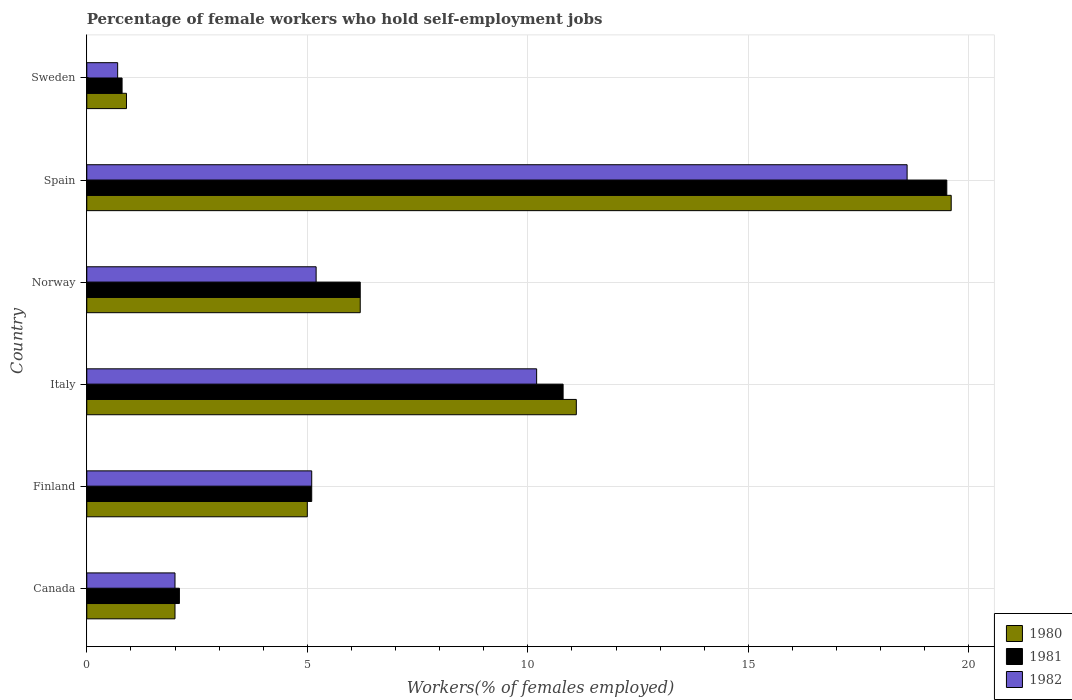How many different coloured bars are there?
Make the answer very short. 3. How many groups of bars are there?
Your answer should be very brief. 6. Are the number of bars per tick equal to the number of legend labels?
Offer a terse response. Yes. Are the number of bars on each tick of the Y-axis equal?
Provide a succinct answer. Yes. How many bars are there on the 1st tick from the bottom?
Give a very brief answer. 3. What is the percentage of self-employed female workers in 1982 in Sweden?
Offer a terse response. 0.7. Across all countries, what is the maximum percentage of self-employed female workers in 1980?
Give a very brief answer. 19.6. Across all countries, what is the minimum percentage of self-employed female workers in 1982?
Your answer should be compact. 0.7. In which country was the percentage of self-employed female workers in 1982 maximum?
Keep it short and to the point. Spain. In which country was the percentage of self-employed female workers in 1980 minimum?
Offer a very short reply. Sweden. What is the total percentage of self-employed female workers in 1981 in the graph?
Provide a succinct answer. 44.5. What is the difference between the percentage of self-employed female workers in 1982 in Canada and that in Finland?
Keep it short and to the point. -3.1. What is the difference between the percentage of self-employed female workers in 1982 in Norway and the percentage of self-employed female workers in 1981 in Sweden?
Make the answer very short. 4.4. What is the average percentage of self-employed female workers in 1981 per country?
Offer a very short reply. 7.42. What is the difference between the percentage of self-employed female workers in 1981 and percentage of self-employed female workers in 1982 in Spain?
Ensure brevity in your answer.  0.9. In how many countries, is the percentage of self-employed female workers in 1980 greater than 9 %?
Keep it short and to the point. 2. What is the ratio of the percentage of self-employed female workers in 1981 in Italy to that in Spain?
Offer a terse response. 0.55. Is the percentage of self-employed female workers in 1982 in Finland less than that in Italy?
Offer a terse response. Yes. What is the difference between the highest and the second highest percentage of self-employed female workers in 1980?
Provide a succinct answer. 8.5. What is the difference between the highest and the lowest percentage of self-employed female workers in 1981?
Keep it short and to the point. 18.7. In how many countries, is the percentage of self-employed female workers in 1980 greater than the average percentage of self-employed female workers in 1980 taken over all countries?
Ensure brevity in your answer.  2. What does the 3rd bar from the bottom in Italy represents?
Your answer should be compact. 1982. Is it the case that in every country, the sum of the percentage of self-employed female workers in 1980 and percentage of self-employed female workers in 1981 is greater than the percentage of self-employed female workers in 1982?
Offer a terse response. Yes. How many bars are there?
Ensure brevity in your answer.  18. How many countries are there in the graph?
Provide a short and direct response. 6. What is the difference between two consecutive major ticks on the X-axis?
Give a very brief answer. 5. Does the graph contain grids?
Provide a short and direct response. Yes. How many legend labels are there?
Keep it short and to the point. 3. How are the legend labels stacked?
Offer a very short reply. Vertical. What is the title of the graph?
Your answer should be compact. Percentage of female workers who hold self-employment jobs. What is the label or title of the X-axis?
Keep it short and to the point. Workers(% of females employed). What is the Workers(% of females employed) in 1981 in Canada?
Your answer should be compact. 2.1. What is the Workers(% of females employed) in 1982 in Canada?
Provide a succinct answer. 2. What is the Workers(% of females employed) of 1980 in Finland?
Offer a very short reply. 5. What is the Workers(% of females employed) of 1981 in Finland?
Your response must be concise. 5.1. What is the Workers(% of females employed) of 1982 in Finland?
Offer a very short reply. 5.1. What is the Workers(% of females employed) of 1980 in Italy?
Give a very brief answer. 11.1. What is the Workers(% of females employed) of 1981 in Italy?
Keep it short and to the point. 10.8. What is the Workers(% of females employed) in 1982 in Italy?
Offer a terse response. 10.2. What is the Workers(% of females employed) in 1980 in Norway?
Provide a succinct answer. 6.2. What is the Workers(% of females employed) in 1981 in Norway?
Provide a short and direct response. 6.2. What is the Workers(% of females employed) of 1982 in Norway?
Your response must be concise. 5.2. What is the Workers(% of females employed) in 1980 in Spain?
Provide a short and direct response. 19.6. What is the Workers(% of females employed) in 1982 in Spain?
Give a very brief answer. 18.6. What is the Workers(% of females employed) in 1980 in Sweden?
Offer a very short reply. 0.9. What is the Workers(% of females employed) in 1981 in Sweden?
Provide a short and direct response. 0.8. What is the Workers(% of females employed) in 1982 in Sweden?
Provide a short and direct response. 0.7. Across all countries, what is the maximum Workers(% of females employed) in 1980?
Give a very brief answer. 19.6. Across all countries, what is the maximum Workers(% of females employed) in 1982?
Give a very brief answer. 18.6. Across all countries, what is the minimum Workers(% of females employed) of 1980?
Provide a short and direct response. 0.9. Across all countries, what is the minimum Workers(% of females employed) of 1981?
Your answer should be compact. 0.8. Across all countries, what is the minimum Workers(% of females employed) of 1982?
Offer a very short reply. 0.7. What is the total Workers(% of females employed) of 1980 in the graph?
Your answer should be compact. 44.8. What is the total Workers(% of females employed) of 1981 in the graph?
Your answer should be very brief. 44.5. What is the total Workers(% of females employed) in 1982 in the graph?
Your answer should be compact. 41.8. What is the difference between the Workers(% of females employed) in 1980 in Canada and that in Italy?
Make the answer very short. -9.1. What is the difference between the Workers(% of females employed) of 1982 in Canada and that in Italy?
Make the answer very short. -8.2. What is the difference between the Workers(% of females employed) in 1980 in Canada and that in Spain?
Provide a short and direct response. -17.6. What is the difference between the Workers(% of females employed) of 1981 in Canada and that in Spain?
Your response must be concise. -17.4. What is the difference between the Workers(% of females employed) of 1982 in Canada and that in Spain?
Make the answer very short. -16.6. What is the difference between the Workers(% of females employed) in 1980 in Canada and that in Sweden?
Offer a terse response. 1.1. What is the difference between the Workers(% of females employed) of 1981 in Finland and that in Italy?
Ensure brevity in your answer.  -5.7. What is the difference between the Workers(% of females employed) in 1982 in Finland and that in Italy?
Offer a terse response. -5.1. What is the difference between the Workers(% of females employed) in 1980 in Finland and that in Spain?
Give a very brief answer. -14.6. What is the difference between the Workers(% of females employed) of 1981 in Finland and that in Spain?
Provide a short and direct response. -14.4. What is the difference between the Workers(% of females employed) in 1980 in Finland and that in Sweden?
Offer a terse response. 4.1. What is the difference between the Workers(% of females employed) of 1981 in Finland and that in Sweden?
Offer a terse response. 4.3. What is the difference between the Workers(% of females employed) of 1982 in Finland and that in Sweden?
Your answer should be compact. 4.4. What is the difference between the Workers(% of females employed) of 1980 in Italy and that in Norway?
Ensure brevity in your answer.  4.9. What is the difference between the Workers(% of females employed) of 1981 in Italy and that in Spain?
Offer a terse response. -8.7. What is the difference between the Workers(% of females employed) of 1982 in Italy and that in Spain?
Keep it short and to the point. -8.4. What is the difference between the Workers(% of females employed) of 1980 in Italy and that in Sweden?
Give a very brief answer. 10.2. What is the difference between the Workers(% of females employed) in 1982 in Italy and that in Sweden?
Provide a succinct answer. 9.5. What is the difference between the Workers(% of females employed) in 1980 in Norway and that in Spain?
Offer a terse response. -13.4. What is the difference between the Workers(% of females employed) of 1981 in Norway and that in Spain?
Ensure brevity in your answer.  -13.3. What is the difference between the Workers(% of females employed) in 1980 in Norway and that in Sweden?
Your answer should be very brief. 5.3. What is the difference between the Workers(% of females employed) of 1981 in Norway and that in Sweden?
Give a very brief answer. 5.4. What is the difference between the Workers(% of females employed) of 1980 in Spain and that in Sweden?
Keep it short and to the point. 18.7. What is the difference between the Workers(% of females employed) in 1980 in Canada and the Workers(% of females employed) in 1981 in Italy?
Offer a terse response. -8.8. What is the difference between the Workers(% of females employed) in 1981 in Canada and the Workers(% of females employed) in 1982 in Italy?
Keep it short and to the point. -8.1. What is the difference between the Workers(% of females employed) in 1980 in Canada and the Workers(% of females employed) in 1981 in Norway?
Make the answer very short. -4.2. What is the difference between the Workers(% of females employed) in 1980 in Canada and the Workers(% of females employed) in 1981 in Spain?
Provide a short and direct response. -17.5. What is the difference between the Workers(% of females employed) of 1980 in Canada and the Workers(% of females employed) of 1982 in Spain?
Provide a succinct answer. -16.6. What is the difference between the Workers(% of females employed) of 1981 in Canada and the Workers(% of females employed) of 1982 in Spain?
Your answer should be very brief. -16.5. What is the difference between the Workers(% of females employed) in 1980 in Canada and the Workers(% of females employed) in 1981 in Sweden?
Your response must be concise. 1.2. What is the difference between the Workers(% of females employed) of 1980 in Canada and the Workers(% of females employed) of 1982 in Sweden?
Your response must be concise. 1.3. What is the difference between the Workers(% of females employed) of 1981 in Finland and the Workers(% of females employed) of 1982 in Norway?
Your response must be concise. -0.1. What is the difference between the Workers(% of females employed) in 1980 in Finland and the Workers(% of females employed) in 1982 in Spain?
Your response must be concise. -13.6. What is the difference between the Workers(% of females employed) in 1981 in Finland and the Workers(% of females employed) in 1982 in Spain?
Give a very brief answer. -13.5. What is the difference between the Workers(% of females employed) of 1980 in Finland and the Workers(% of females employed) of 1981 in Sweden?
Your response must be concise. 4.2. What is the difference between the Workers(% of females employed) of 1981 in Finland and the Workers(% of females employed) of 1982 in Sweden?
Provide a short and direct response. 4.4. What is the difference between the Workers(% of females employed) in 1980 in Italy and the Workers(% of females employed) in 1981 in Norway?
Keep it short and to the point. 4.9. What is the difference between the Workers(% of females employed) in 1981 in Italy and the Workers(% of females employed) in 1982 in Spain?
Keep it short and to the point. -7.8. What is the difference between the Workers(% of females employed) of 1980 in Italy and the Workers(% of females employed) of 1981 in Sweden?
Give a very brief answer. 10.3. What is the difference between the Workers(% of females employed) in 1981 in Italy and the Workers(% of females employed) in 1982 in Sweden?
Offer a terse response. 10.1. What is the difference between the Workers(% of females employed) in 1981 in Norway and the Workers(% of females employed) in 1982 in Spain?
Make the answer very short. -12.4. What is the difference between the Workers(% of females employed) of 1980 in Norway and the Workers(% of females employed) of 1981 in Sweden?
Provide a short and direct response. 5.4. What is the difference between the Workers(% of females employed) of 1980 in Norway and the Workers(% of females employed) of 1982 in Sweden?
Provide a short and direct response. 5.5. What is the difference between the Workers(% of females employed) of 1980 in Spain and the Workers(% of females employed) of 1982 in Sweden?
Offer a very short reply. 18.9. What is the average Workers(% of females employed) of 1980 per country?
Keep it short and to the point. 7.47. What is the average Workers(% of females employed) in 1981 per country?
Give a very brief answer. 7.42. What is the average Workers(% of females employed) of 1982 per country?
Offer a very short reply. 6.97. What is the difference between the Workers(% of females employed) in 1980 and Workers(% of females employed) in 1981 in Canada?
Your response must be concise. -0.1. What is the difference between the Workers(% of females employed) of 1980 and Workers(% of females employed) of 1982 in Canada?
Ensure brevity in your answer.  0. What is the difference between the Workers(% of females employed) in 1981 and Workers(% of females employed) in 1982 in Finland?
Ensure brevity in your answer.  0. What is the difference between the Workers(% of females employed) of 1981 and Workers(% of females employed) of 1982 in Norway?
Your response must be concise. 1. What is the difference between the Workers(% of females employed) in 1980 and Workers(% of females employed) in 1982 in Sweden?
Your answer should be very brief. 0.2. What is the difference between the Workers(% of females employed) in 1981 and Workers(% of females employed) in 1982 in Sweden?
Ensure brevity in your answer.  0.1. What is the ratio of the Workers(% of females employed) of 1980 in Canada to that in Finland?
Offer a very short reply. 0.4. What is the ratio of the Workers(% of females employed) of 1981 in Canada to that in Finland?
Your response must be concise. 0.41. What is the ratio of the Workers(% of females employed) in 1982 in Canada to that in Finland?
Ensure brevity in your answer.  0.39. What is the ratio of the Workers(% of females employed) in 1980 in Canada to that in Italy?
Provide a short and direct response. 0.18. What is the ratio of the Workers(% of females employed) in 1981 in Canada to that in Italy?
Offer a terse response. 0.19. What is the ratio of the Workers(% of females employed) in 1982 in Canada to that in Italy?
Provide a succinct answer. 0.2. What is the ratio of the Workers(% of females employed) of 1980 in Canada to that in Norway?
Offer a very short reply. 0.32. What is the ratio of the Workers(% of females employed) in 1981 in Canada to that in Norway?
Give a very brief answer. 0.34. What is the ratio of the Workers(% of females employed) in 1982 in Canada to that in Norway?
Provide a succinct answer. 0.38. What is the ratio of the Workers(% of females employed) of 1980 in Canada to that in Spain?
Give a very brief answer. 0.1. What is the ratio of the Workers(% of females employed) in 1981 in Canada to that in Spain?
Provide a short and direct response. 0.11. What is the ratio of the Workers(% of females employed) in 1982 in Canada to that in Spain?
Make the answer very short. 0.11. What is the ratio of the Workers(% of females employed) in 1980 in Canada to that in Sweden?
Your answer should be compact. 2.22. What is the ratio of the Workers(% of females employed) of 1981 in Canada to that in Sweden?
Give a very brief answer. 2.62. What is the ratio of the Workers(% of females employed) of 1982 in Canada to that in Sweden?
Give a very brief answer. 2.86. What is the ratio of the Workers(% of females employed) in 1980 in Finland to that in Italy?
Offer a terse response. 0.45. What is the ratio of the Workers(% of females employed) of 1981 in Finland to that in Italy?
Provide a succinct answer. 0.47. What is the ratio of the Workers(% of females employed) of 1982 in Finland to that in Italy?
Keep it short and to the point. 0.5. What is the ratio of the Workers(% of females employed) in 1980 in Finland to that in Norway?
Your answer should be compact. 0.81. What is the ratio of the Workers(% of females employed) of 1981 in Finland to that in Norway?
Your answer should be very brief. 0.82. What is the ratio of the Workers(% of females employed) in 1982 in Finland to that in Norway?
Your answer should be very brief. 0.98. What is the ratio of the Workers(% of females employed) of 1980 in Finland to that in Spain?
Provide a short and direct response. 0.26. What is the ratio of the Workers(% of females employed) of 1981 in Finland to that in Spain?
Provide a short and direct response. 0.26. What is the ratio of the Workers(% of females employed) in 1982 in Finland to that in Spain?
Offer a terse response. 0.27. What is the ratio of the Workers(% of females employed) of 1980 in Finland to that in Sweden?
Make the answer very short. 5.56. What is the ratio of the Workers(% of females employed) in 1981 in Finland to that in Sweden?
Provide a succinct answer. 6.38. What is the ratio of the Workers(% of females employed) of 1982 in Finland to that in Sweden?
Your answer should be compact. 7.29. What is the ratio of the Workers(% of females employed) in 1980 in Italy to that in Norway?
Make the answer very short. 1.79. What is the ratio of the Workers(% of females employed) in 1981 in Italy to that in Norway?
Keep it short and to the point. 1.74. What is the ratio of the Workers(% of females employed) of 1982 in Italy to that in Norway?
Give a very brief answer. 1.96. What is the ratio of the Workers(% of females employed) of 1980 in Italy to that in Spain?
Your answer should be very brief. 0.57. What is the ratio of the Workers(% of females employed) in 1981 in Italy to that in Spain?
Offer a very short reply. 0.55. What is the ratio of the Workers(% of females employed) in 1982 in Italy to that in Spain?
Your answer should be very brief. 0.55. What is the ratio of the Workers(% of females employed) of 1980 in Italy to that in Sweden?
Offer a very short reply. 12.33. What is the ratio of the Workers(% of females employed) of 1982 in Italy to that in Sweden?
Give a very brief answer. 14.57. What is the ratio of the Workers(% of females employed) in 1980 in Norway to that in Spain?
Provide a succinct answer. 0.32. What is the ratio of the Workers(% of females employed) of 1981 in Norway to that in Spain?
Ensure brevity in your answer.  0.32. What is the ratio of the Workers(% of females employed) in 1982 in Norway to that in Spain?
Make the answer very short. 0.28. What is the ratio of the Workers(% of females employed) in 1980 in Norway to that in Sweden?
Ensure brevity in your answer.  6.89. What is the ratio of the Workers(% of females employed) in 1981 in Norway to that in Sweden?
Give a very brief answer. 7.75. What is the ratio of the Workers(% of females employed) in 1982 in Norway to that in Sweden?
Your response must be concise. 7.43. What is the ratio of the Workers(% of females employed) of 1980 in Spain to that in Sweden?
Ensure brevity in your answer.  21.78. What is the ratio of the Workers(% of females employed) of 1981 in Spain to that in Sweden?
Your response must be concise. 24.38. What is the ratio of the Workers(% of females employed) in 1982 in Spain to that in Sweden?
Keep it short and to the point. 26.57. What is the difference between the highest and the second highest Workers(% of females employed) of 1980?
Your answer should be very brief. 8.5. What is the difference between the highest and the second highest Workers(% of females employed) of 1982?
Offer a very short reply. 8.4. What is the difference between the highest and the lowest Workers(% of females employed) in 1982?
Provide a succinct answer. 17.9. 